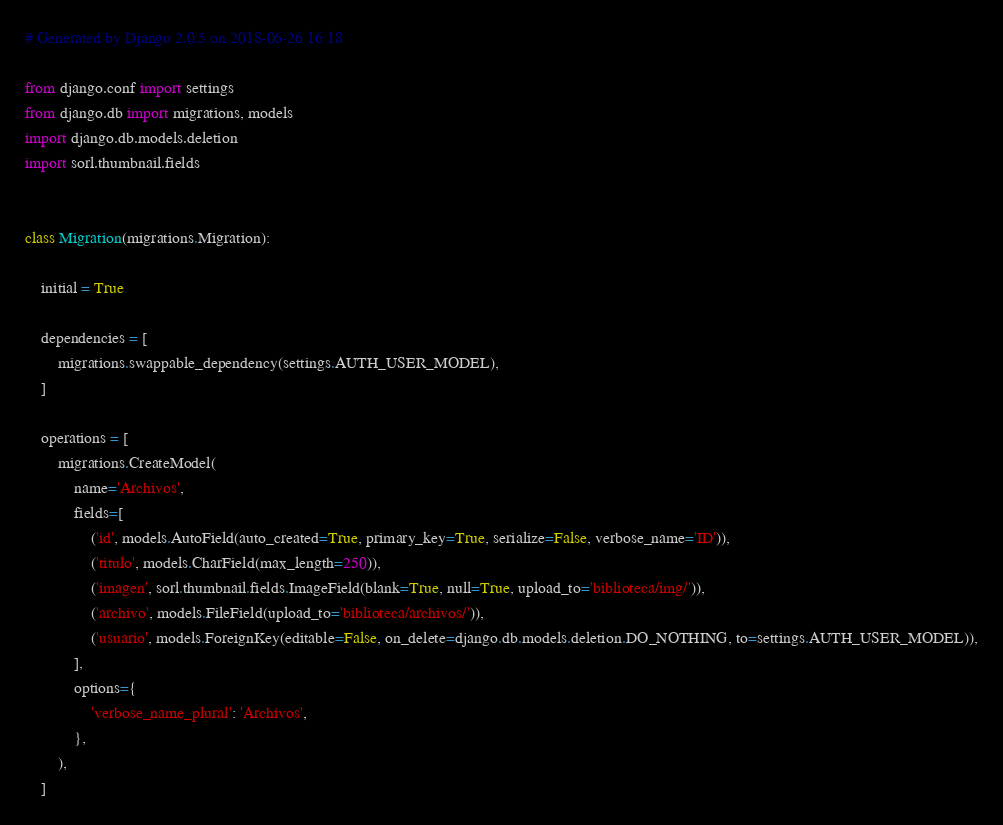<code> <loc_0><loc_0><loc_500><loc_500><_Python_># Generated by Django 2.0.5 on 2018-06-26 16:18

from django.conf import settings
from django.db import migrations, models
import django.db.models.deletion
import sorl.thumbnail.fields


class Migration(migrations.Migration):

    initial = True

    dependencies = [
        migrations.swappable_dependency(settings.AUTH_USER_MODEL),
    ]

    operations = [
        migrations.CreateModel(
            name='Archivos',
            fields=[
                ('id', models.AutoField(auto_created=True, primary_key=True, serialize=False, verbose_name='ID')),
                ('titulo', models.CharField(max_length=250)),
                ('imagen', sorl.thumbnail.fields.ImageField(blank=True, null=True, upload_to='biblioteca/img/')),
                ('archivo', models.FileField(upload_to='biblioteca/archivos/')),
                ('usuario', models.ForeignKey(editable=False, on_delete=django.db.models.deletion.DO_NOTHING, to=settings.AUTH_USER_MODEL)),
            ],
            options={
                'verbose_name_plural': 'Archivos',
            },
        ),
    ]
</code> 